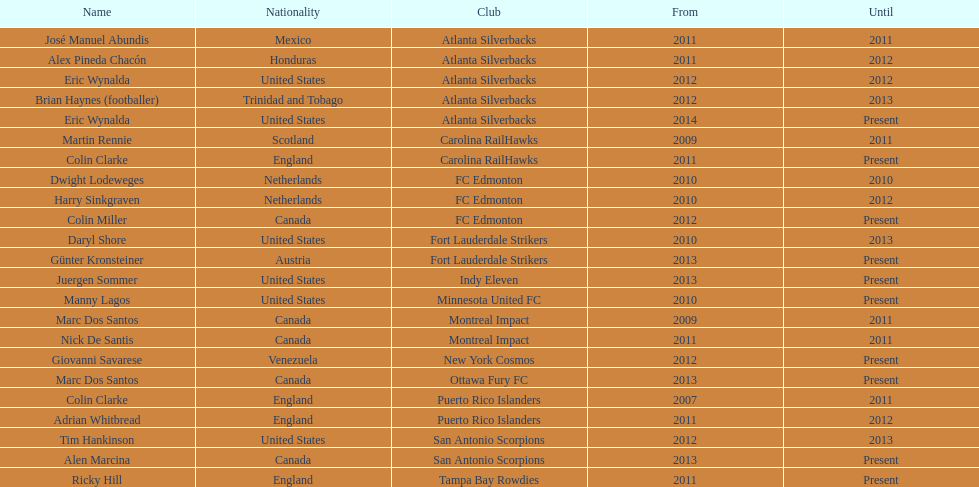In which year did marc dos santos begin his coaching career? 2009. Additionally, which other coach also started in 2009 aside from marc dos santos? Martin Rennie. 